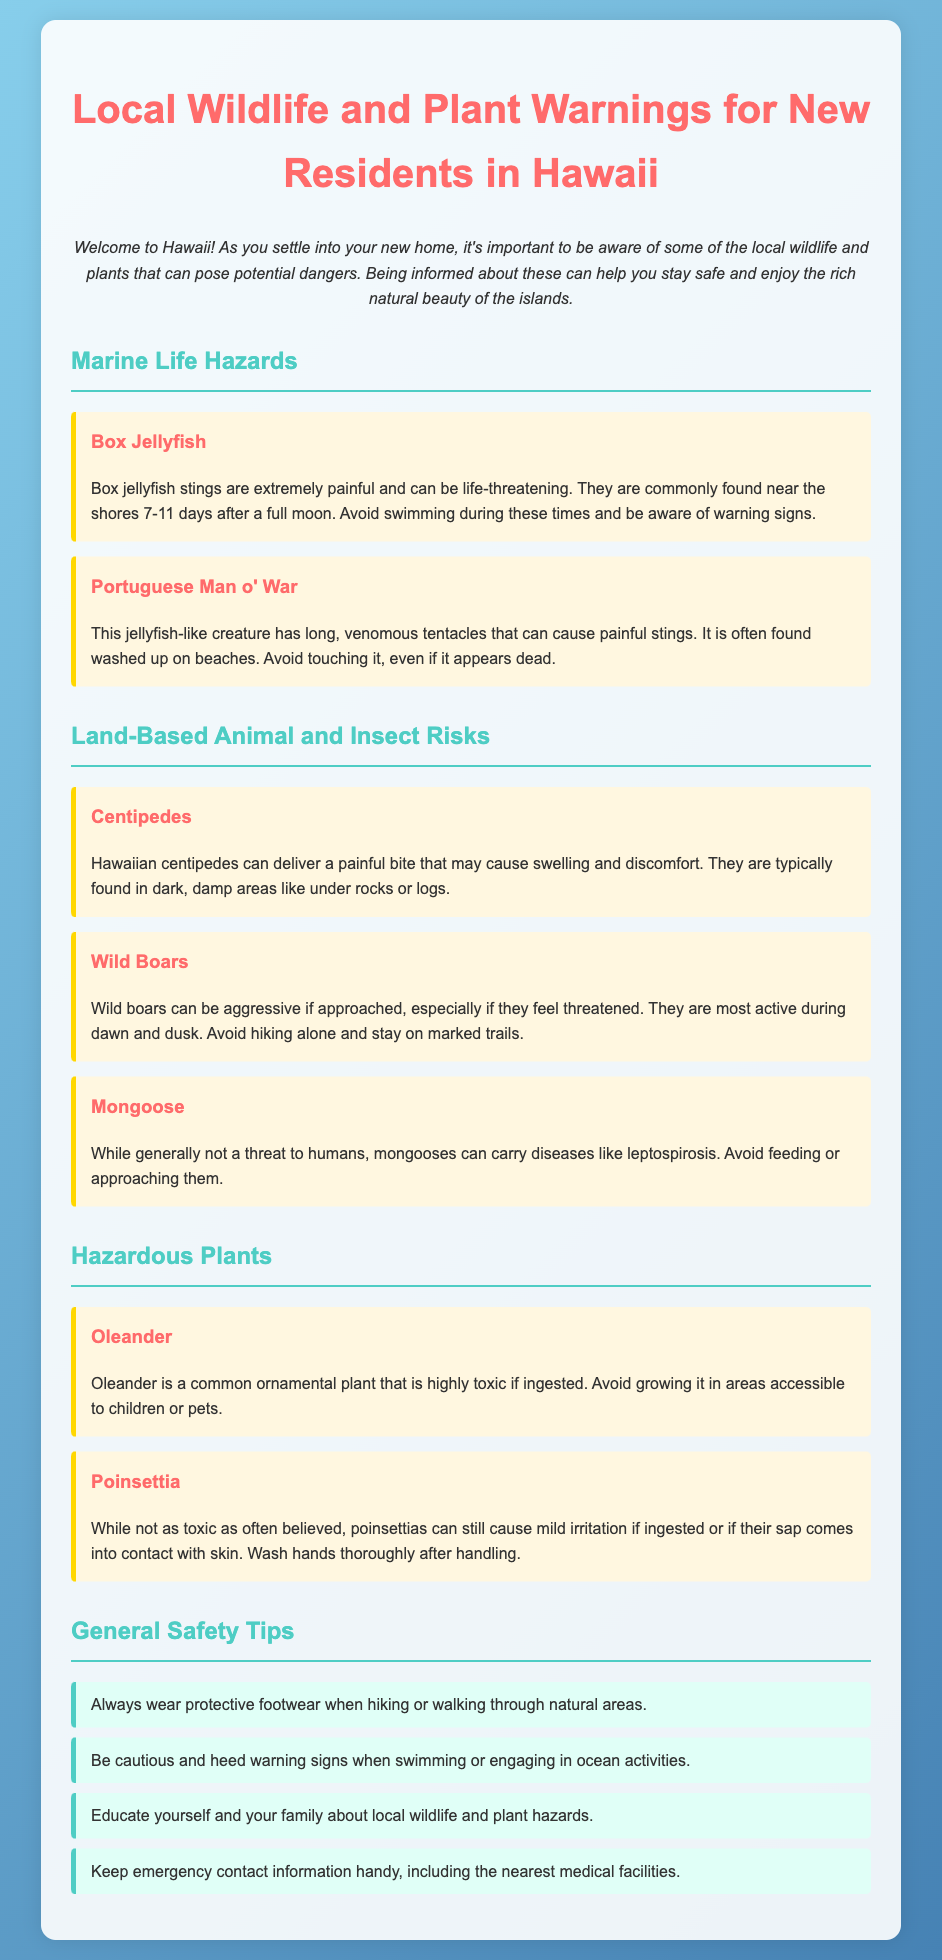What dangerous marine creature is commonly found near the shores after a full moon? The document mentions that box jellyfish are commonly found near the shores 7-11 days after a full moon and can cause painful stings that may be life-threatening.
Answer: Box jellyfish What should you do if you encounter a Portuguese Man o' War on the beach? The document advises to avoid touching it, even if it appears dead, due to its venomous tentacles that can cause painful stings.
Answer: Avoid touching it Which animal can deliver a painful bite and is found in dark, damp areas? The document states that Hawaiian centipedes can deliver painful bites and are typically found in dark, damp areas like under rocks or logs.
Answer: Centipedes What is a key safety tip when hiking in Hawaii? The document provides a safety tip that emphasizes the importance of wearing protective footwear when hiking or walking through natural areas.
Answer: Wear protective footwear Is Oleander toxic if ingested? The document highlights that Oleander is highly toxic if ingested and should be kept away from children or pets.
Answer: Yes What time of day are wild boars most active? The document indicates that wild boars are most active during dawn and dusk, making them potentially aggressive if approached.
Answer: Dawn and dusk How might mongooses impact human health? The document mentions that mongooses can carry diseases like leptospirosis, hence should not be fed or approached.
Answer: Diseases like leptospirosis What type of irritation can come from handling a Poinsettia? According to the document, Poinsettias can cause mild irritation if their sap comes into contact with skin or if ingested.
Answer: Mild irritation How many general safety tips are provided in the document? The document lists a total of four general safety tips regarding wildlife and plant hazards for new residents in Hawaii.
Answer: Four 